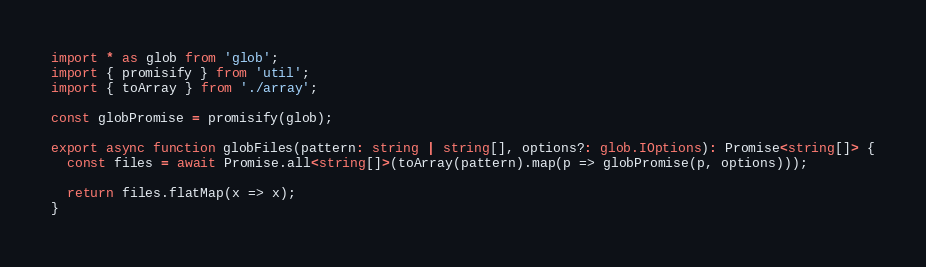<code> <loc_0><loc_0><loc_500><loc_500><_TypeScript_>import * as glob from 'glob';
import { promisify } from 'util';
import { toArray } from './array';

const globPromise = promisify(glob);

export async function globFiles(pattern: string | string[], options?: glob.IOptions): Promise<string[]> {
  const files = await Promise.all<string[]>(toArray(pattern).map(p => globPromise(p, options)));

  return files.flatMap(x => x);
}
</code> 